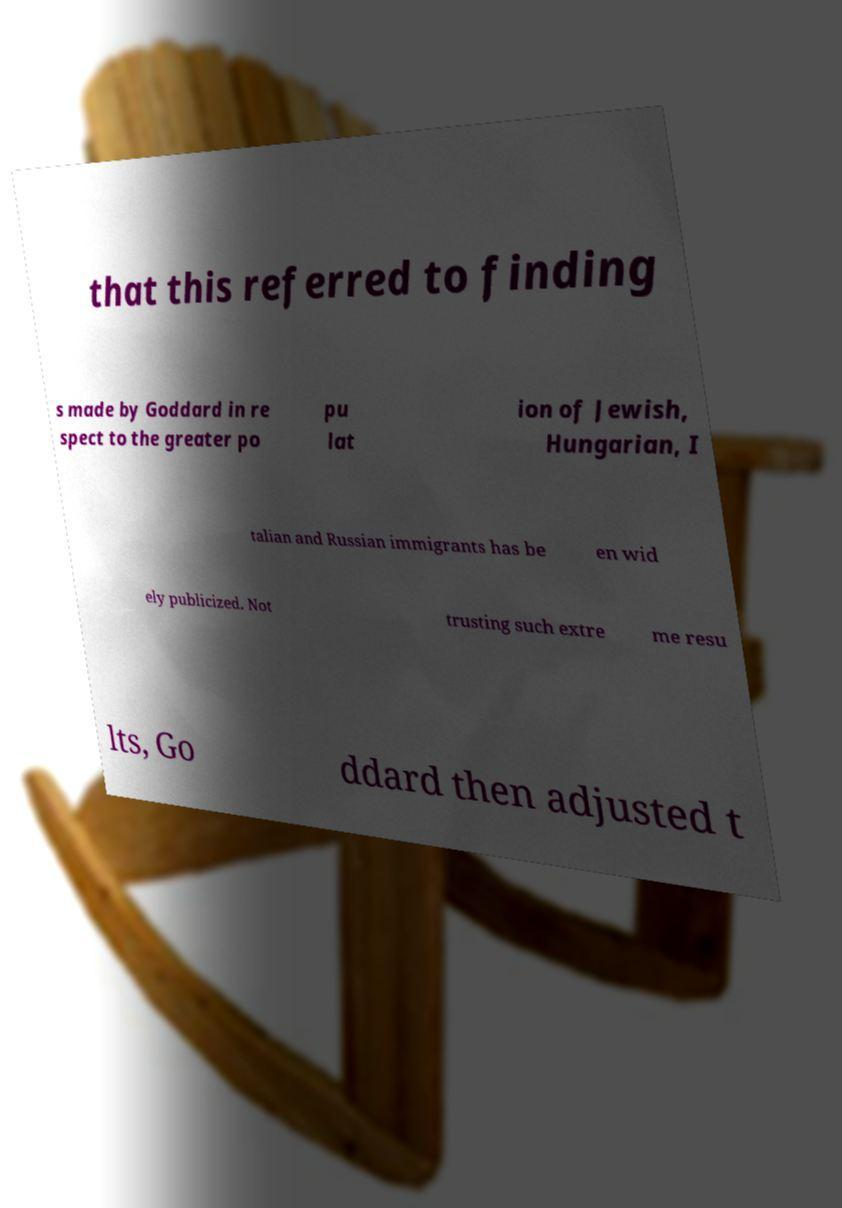For documentation purposes, I need the text within this image transcribed. Could you provide that? that this referred to finding s made by Goddard in re spect to the greater po pu lat ion of Jewish, Hungarian, I talian and Russian immigrants has be en wid ely publicized. Not trusting such extre me resu lts, Go ddard then adjusted t 